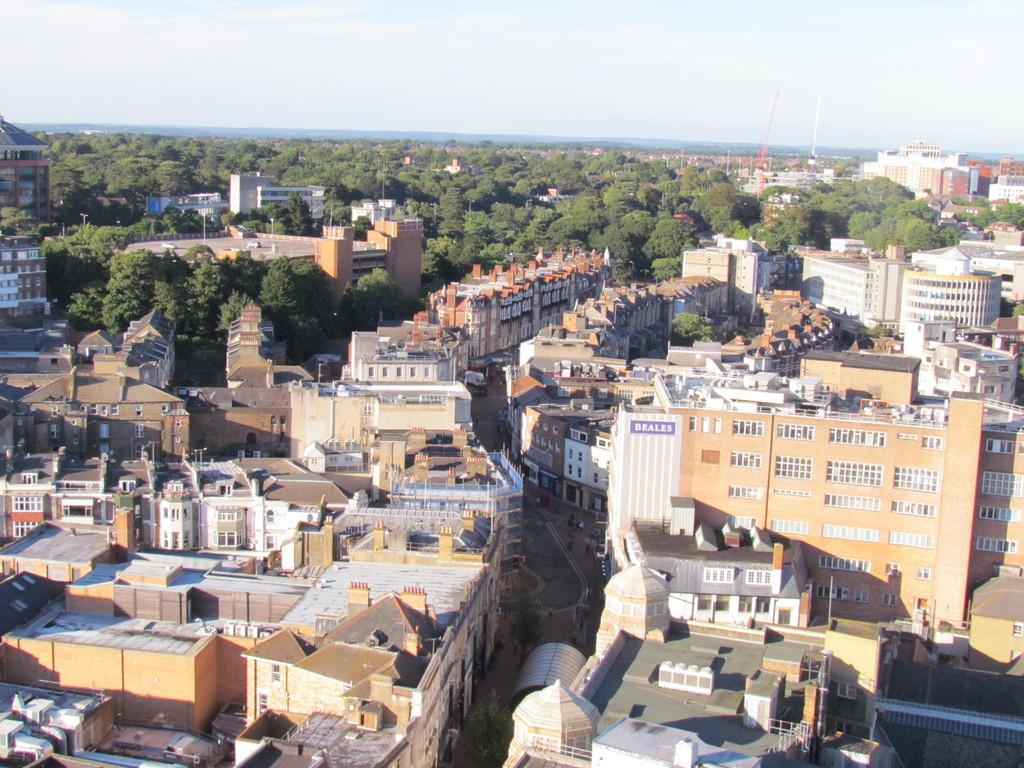Who or what can be seen in the image? There are people in the image. What else is visible on the ground in the image? There are vehicles on the road in the image. What structures are present in the image? There are buildings in the image. What can be seen in the distance in the image? Trees are visible in the background of the image. What is visible in the sky in the background of the image? Clouds are present in the sky in the background of the image. What type of veil is being used by the people in the image? There is no veil present in the image; the people are not wearing any veils. 